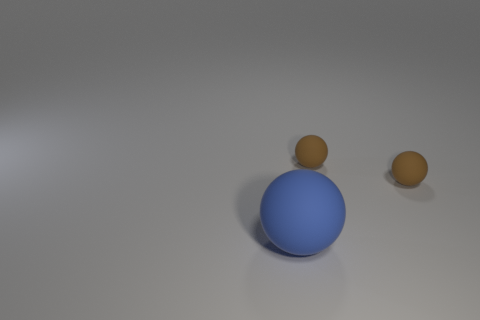How many small matte things are the same shape as the big blue thing? There are two small, matte brown spheres present in the image, which are the same shape as the larger, glossy blue sphere situated centrally. 